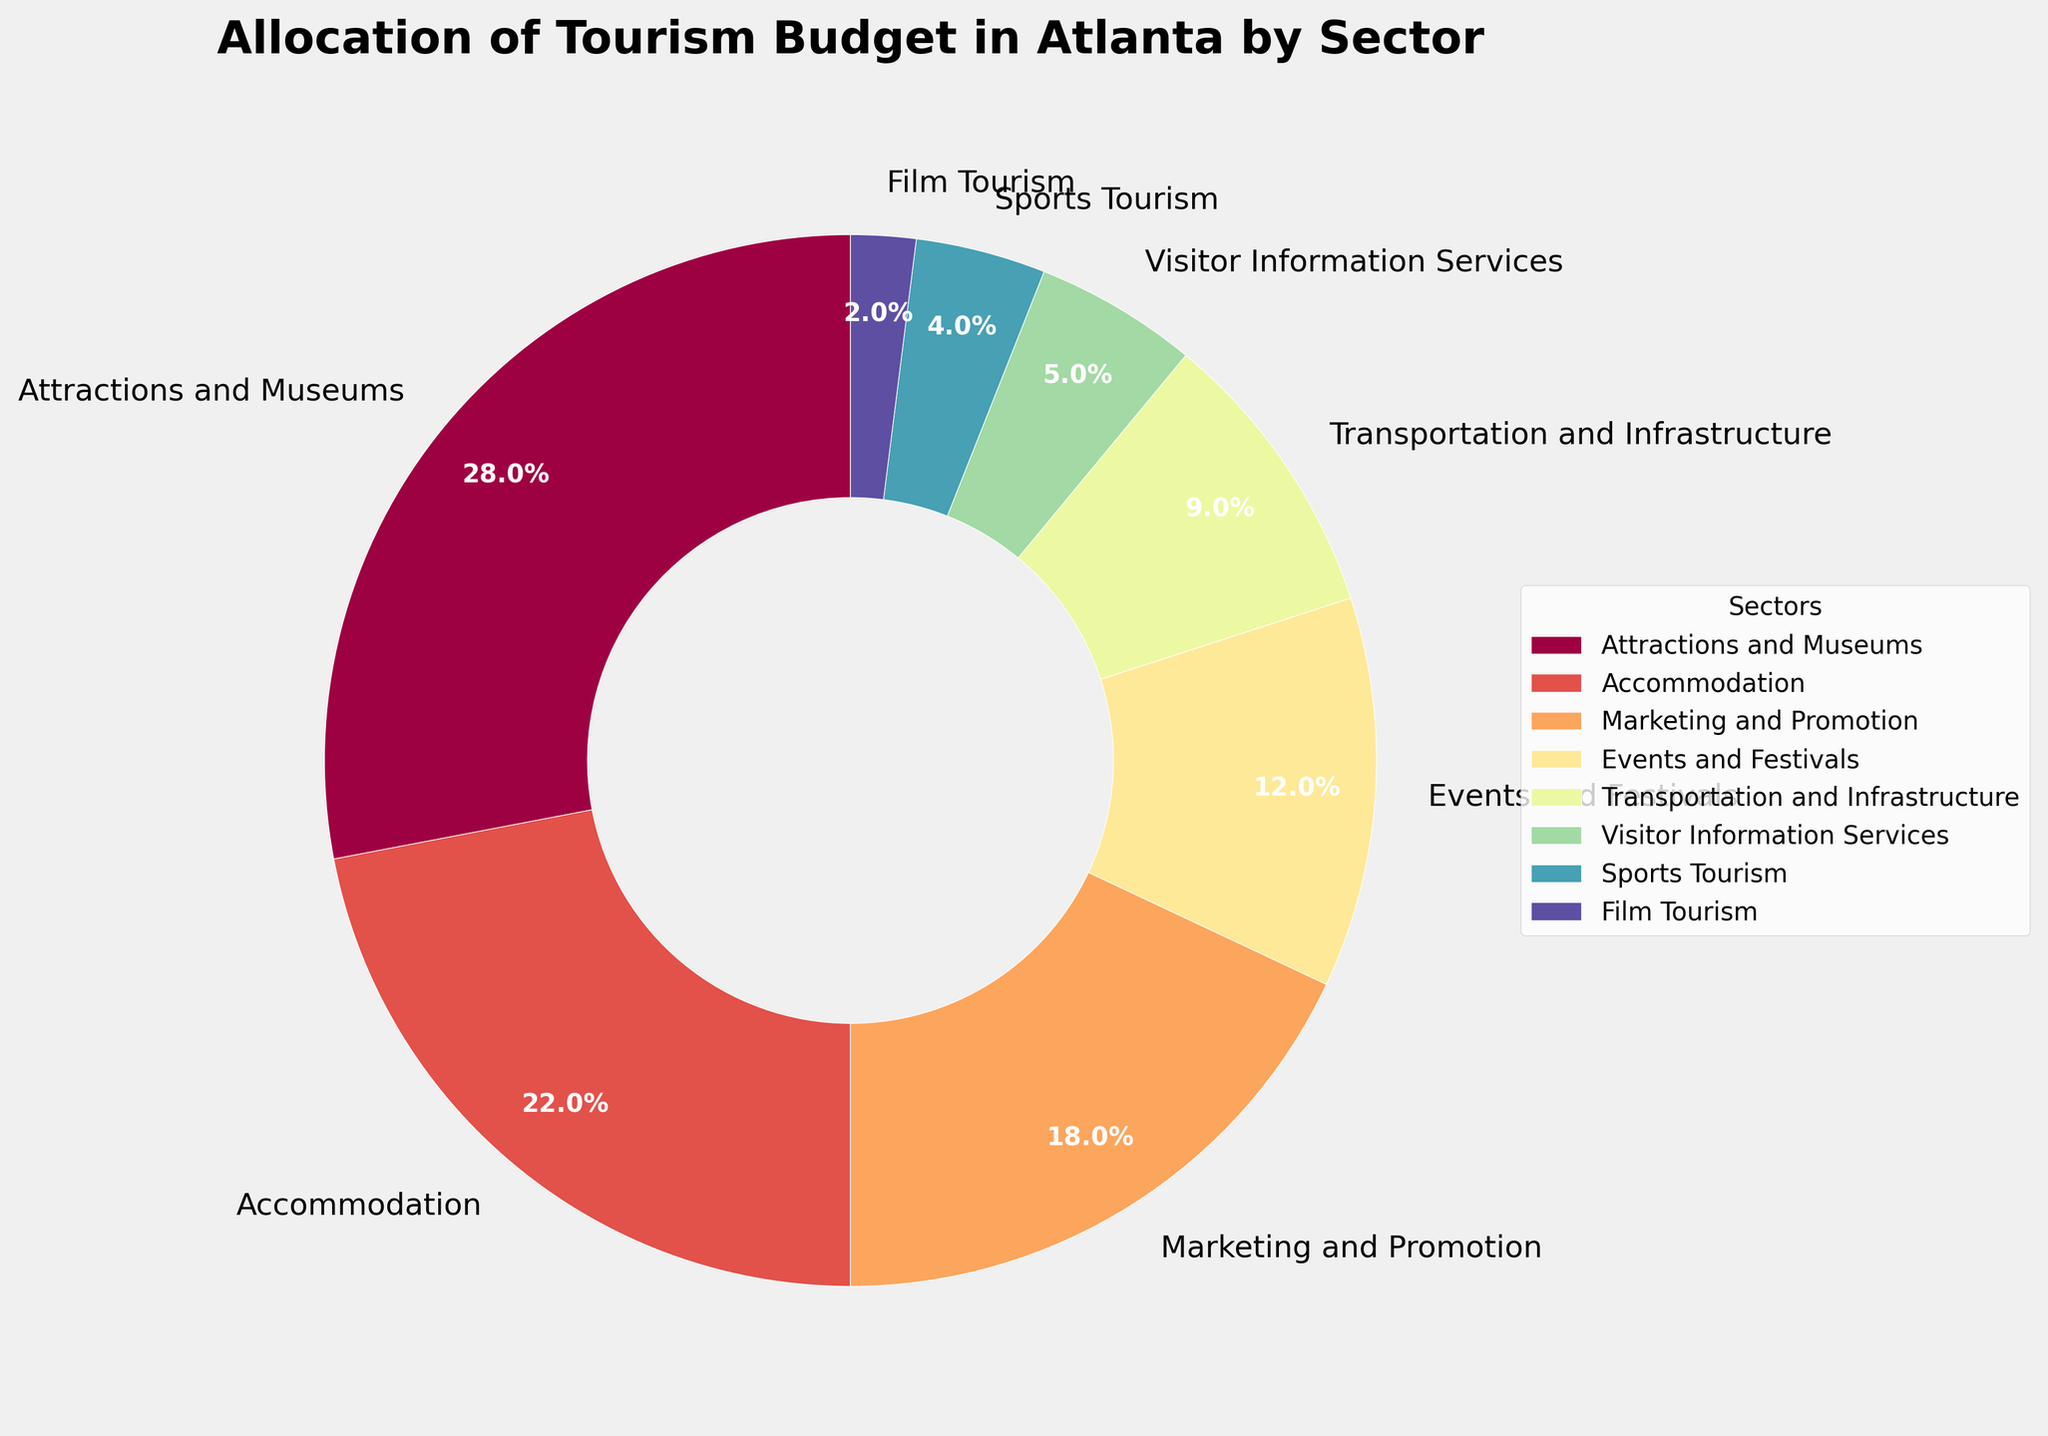What's the largest sector in terms of budget allocation? The largest sector can be determined by looking at the sector with the highest percentage. According to the figure, "Attractions and Museums" has the highest percentage at 28%.
Answer: Attractions and Museums Which two sectors have the smallest budget allocations? The smallest sectors have the lowest percentages. By examining the figure, "Film Tourism" (2%) and "Sports Tourism" (4%) are the smallest sectors.
Answer: Film Tourism and Sports Tourism What is the combined budget allocation for Events and Festivals and Transportation and Infrastructure? To find the combined allocation, add the percentages for both sectors: 12% (Events and Festivals) + 9% (Transportation and Infrastructure) = 21%.
Answer: 21% How does the budget allocation for Marketing and Promotion compare to that for Accommodation? According to the figure, "Marketing and Promotion" is 18%, while "Accommodation" is 22%. Comparing these, "Accommodation" has a higher allocation.
Answer: Accommodation is higher Which sectors together make up more than half of the total budget? To determine which sectors together make up more than 50%, start summing the largest percentages first: 28% (Attractions and Museums) + 22% (Accommodation) = 50%. Adding the next segment (18% for Marketing and Promotion) gives a total of 68%, which is more than half. Therefore, "Attractions and Museums," "Accommodation," and "Marketing and Promotion" together make up more than half.
Answer: Attractions and Museums, Accommodation, Marketing and Promotion What is the difference in budget allocation between the highest and lowest sectors? The highest allocation is for "Attractions and Museums" at 28%, and the lowest is for "Film Tourism" at 2%. The difference between them is calculated as 28% - 2% = 26%.
Answer: 26% How much more budget is allocated to Attractions and Museums compared to Visitor Information Services? Comparing "Attractions and Museums" at 28% with "Visitor Information Services" at 5%, the difference is 28% - 5% = 23%.
Answer: 23% What proportion of the budget is allocated to sectors other than the top three? The top three sectors are: "Attractions and Museums" (28%), "Accommodation" (22%), and "Marketing and Promotion" (18%). First, sum these top three: 28% + 22% + 18% = 68%. Then, subtract from 100% to find the rest: 100% - 68% = 32%.
Answer: 32% Is the budget for Marketing and Promotion more than double that for Sports Tourism? The allocation for "Marketing and Promotion" is 18% and for "Sports Tourism" is 4%. Doubling the Sports Tourism budget gives 4% * 2 = 8%. Since 18% is more than 8%, the allocation for Marketing and Promotion is indeed more than double that of Sports Tourism.
Answer: Yes 